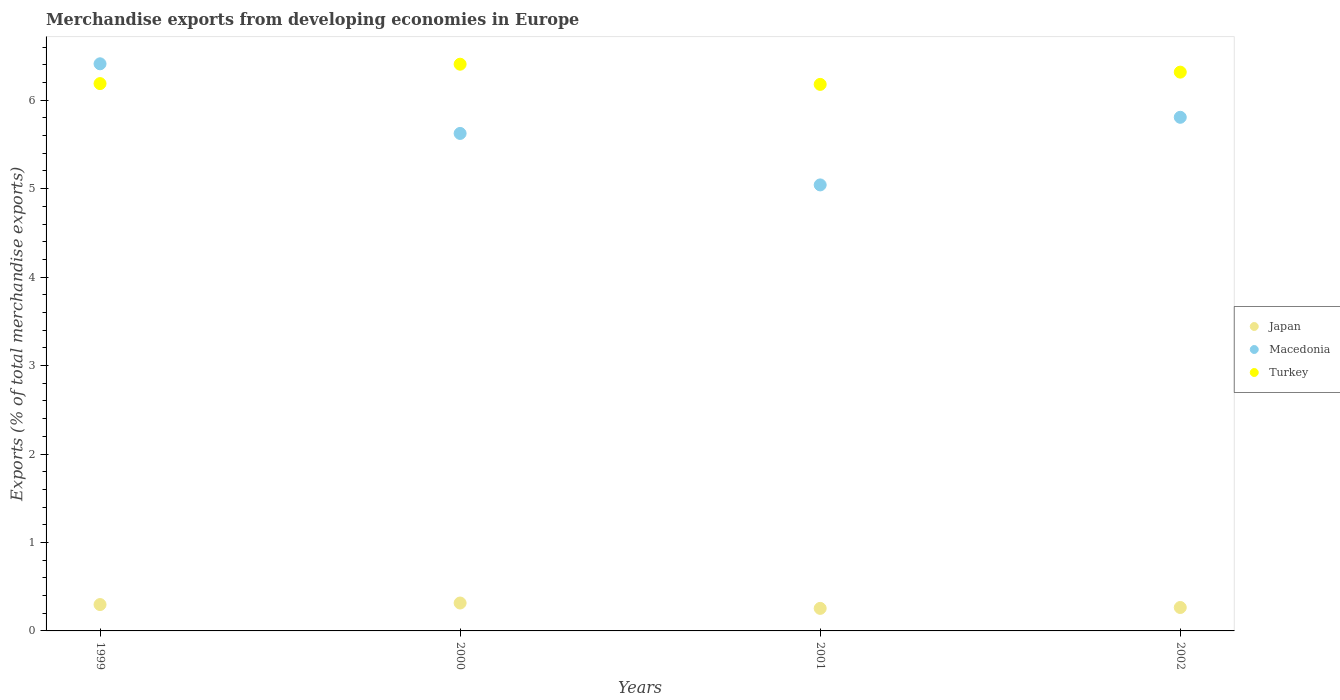How many different coloured dotlines are there?
Give a very brief answer. 3. Is the number of dotlines equal to the number of legend labels?
Offer a terse response. Yes. What is the percentage of total merchandise exports in Macedonia in 2001?
Provide a succinct answer. 5.04. Across all years, what is the maximum percentage of total merchandise exports in Turkey?
Offer a very short reply. 6.41. Across all years, what is the minimum percentage of total merchandise exports in Japan?
Give a very brief answer. 0.25. In which year was the percentage of total merchandise exports in Japan maximum?
Offer a very short reply. 2000. In which year was the percentage of total merchandise exports in Macedonia minimum?
Give a very brief answer. 2001. What is the total percentage of total merchandise exports in Turkey in the graph?
Your answer should be compact. 25.09. What is the difference between the percentage of total merchandise exports in Macedonia in 2000 and that in 2001?
Keep it short and to the point. 0.58. What is the difference between the percentage of total merchandise exports in Turkey in 2002 and the percentage of total merchandise exports in Japan in 1999?
Provide a short and direct response. 6.02. What is the average percentage of total merchandise exports in Turkey per year?
Your answer should be very brief. 6.27. In the year 2001, what is the difference between the percentage of total merchandise exports in Japan and percentage of total merchandise exports in Turkey?
Keep it short and to the point. -5.92. In how many years, is the percentage of total merchandise exports in Turkey greater than 4 %?
Keep it short and to the point. 4. What is the ratio of the percentage of total merchandise exports in Macedonia in 1999 to that in 2001?
Keep it short and to the point. 1.27. Is the difference between the percentage of total merchandise exports in Japan in 2000 and 2002 greater than the difference between the percentage of total merchandise exports in Turkey in 2000 and 2002?
Give a very brief answer. No. What is the difference between the highest and the second highest percentage of total merchandise exports in Turkey?
Provide a succinct answer. 0.09. What is the difference between the highest and the lowest percentage of total merchandise exports in Turkey?
Provide a succinct answer. 0.23. In how many years, is the percentage of total merchandise exports in Macedonia greater than the average percentage of total merchandise exports in Macedonia taken over all years?
Give a very brief answer. 2. Is it the case that in every year, the sum of the percentage of total merchandise exports in Macedonia and percentage of total merchandise exports in Japan  is greater than the percentage of total merchandise exports in Turkey?
Give a very brief answer. No. What is the difference between two consecutive major ticks on the Y-axis?
Offer a terse response. 1. Does the graph contain grids?
Provide a short and direct response. No. What is the title of the graph?
Give a very brief answer. Merchandise exports from developing economies in Europe. What is the label or title of the Y-axis?
Your response must be concise. Exports (% of total merchandise exports). What is the Exports (% of total merchandise exports) of Japan in 1999?
Your response must be concise. 0.3. What is the Exports (% of total merchandise exports) in Macedonia in 1999?
Offer a terse response. 6.41. What is the Exports (% of total merchandise exports) in Turkey in 1999?
Keep it short and to the point. 6.19. What is the Exports (% of total merchandise exports) in Japan in 2000?
Offer a very short reply. 0.32. What is the Exports (% of total merchandise exports) of Macedonia in 2000?
Give a very brief answer. 5.62. What is the Exports (% of total merchandise exports) of Turkey in 2000?
Ensure brevity in your answer.  6.41. What is the Exports (% of total merchandise exports) of Japan in 2001?
Ensure brevity in your answer.  0.25. What is the Exports (% of total merchandise exports) in Macedonia in 2001?
Provide a succinct answer. 5.04. What is the Exports (% of total merchandise exports) of Turkey in 2001?
Give a very brief answer. 6.18. What is the Exports (% of total merchandise exports) of Japan in 2002?
Keep it short and to the point. 0.26. What is the Exports (% of total merchandise exports) of Macedonia in 2002?
Make the answer very short. 5.81. What is the Exports (% of total merchandise exports) of Turkey in 2002?
Give a very brief answer. 6.32. Across all years, what is the maximum Exports (% of total merchandise exports) in Japan?
Your answer should be compact. 0.32. Across all years, what is the maximum Exports (% of total merchandise exports) in Macedonia?
Provide a succinct answer. 6.41. Across all years, what is the maximum Exports (% of total merchandise exports) of Turkey?
Ensure brevity in your answer.  6.41. Across all years, what is the minimum Exports (% of total merchandise exports) of Japan?
Your answer should be compact. 0.25. Across all years, what is the minimum Exports (% of total merchandise exports) of Macedonia?
Ensure brevity in your answer.  5.04. Across all years, what is the minimum Exports (% of total merchandise exports) in Turkey?
Make the answer very short. 6.18. What is the total Exports (% of total merchandise exports) of Japan in the graph?
Your answer should be very brief. 1.13. What is the total Exports (% of total merchandise exports) in Macedonia in the graph?
Offer a very short reply. 22.89. What is the total Exports (% of total merchandise exports) of Turkey in the graph?
Your answer should be very brief. 25.09. What is the difference between the Exports (% of total merchandise exports) of Japan in 1999 and that in 2000?
Your answer should be very brief. -0.02. What is the difference between the Exports (% of total merchandise exports) of Macedonia in 1999 and that in 2000?
Your answer should be very brief. 0.79. What is the difference between the Exports (% of total merchandise exports) of Turkey in 1999 and that in 2000?
Your answer should be compact. -0.22. What is the difference between the Exports (% of total merchandise exports) in Japan in 1999 and that in 2001?
Give a very brief answer. 0.04. What is the difference between the Exports (% of total merchandise exports) of Macedonia in 1999 and that in 2001?
Offer a very short reply. 1.37. What is the difference between the Exports (% of total merchandise exports) in Turkey in 1999 and that in 2001?
Offer a very short reply. 0.01. What is the difference between the Exports (% of total merchandise exports) in Japan in 1999 and that in 2002?
Ensure brevity in your answer.  0.03. What is the difference between the Exports (% of total merchandise exports) in Macedonia in 1999 and that in 2002?
Give a very brief answer. 0.6. What is the difference between the Exports (% of total merchandise exports) in Turkey in 1999 and that in 2002?
Provide a succinct answer. -0.13. What is the difference between the Exports (% of total merchandise exports) of Japan in 2000 and that in 2001?
Your answer should be very brief. 0.06. What is the difference between the Exports (% of total merchandise exports) in Macedonia in 2000 and that in 2001?
Offer a terse response. 0.58. What is the difference between the Exports (% of total merchandise exports) of Turkey in 2000 and that in 2001?
Offer a very short reply. 0.23. What is the difference between the Exports (% of total merchandise exports) of Japan in 2000 and that in 2002?
Give a very brief answer. 0.05. What is the difference between the Exports (% of total merchandise exports) of Macedonia in 2000 and that in 2002?
Provide a short and direct response. -0.18. What is the difference between the Exports (% of total merchandise exports) in Turkey in 2000 and that in 2002?
Offer a very short reply. 0.09. What is the difference between the Exports (% of total merchandise exports) of Japan in 2001 and that in 2002?
Ensure brevity in your answer.  -0.01. What is the difference between the Exports (% of total merchandise exports) in Macedonia in 2001 and that in 2002?
Your answer should be compact. -0.76. What is the difference between the Exports (% of total merchandise exports) in Turkey in 2001 and that in 2002?
Provide a succinct answer. -0.14. What is the difference between the Exports (% of total merchandise exports) in Japan in 1999 and the Exports (% of total merchandise exports) in Macedonia in 2000?
Keep it short and to the point. -5.33. What is the difference between the Exports (% of total merchandise exports) in Japan in 1999 and the Exports (% of total merchandise exports) in Turkey in 2000?
Provide a succinct answer. -6.11. What is the difference between the Exports (% of total merchandise exports) in Macedonia in 1999 and the Exports (% of total merchandise exports) in Turkey in 2000?
Offer a very short reply. 0. What is the difference between the Exports (% of total merchandise exports) of Japan in 1999 and the Exports (% of total merchandise exports) of Macedonia in 2001?
Offer a very short reply. -4.74. What is the difference between the Exports (% of total merchandise exports) of Japan in 1999 and the Exports (% of total merchandise exports) of Turkey in 2001?
Offer a very short reply. -5.88. What is the difference between the Exports (% of total merchandise exports) in Macedonia in 1999 and the Exports (% of total merchandise exports) in Turkey in 2001?
Your answer should be compact. 0.23. What is the difference between the Exports (% of total merchandise exports) of Japan in 1999 and the Exports (% of total merchandise exports) of Macedonia in 2002?
Keep it short and to the point. -5.51. What is the difference between the Exports (% of total merchandise exports) of Japan in 1999 and the Exports (% of total merchandise exports) of Turkey in 2002?
Your answer should be compact. -6.02. What is the difference between the Exports (% of total merchandise exports) in Macedonia in 1999 and the Exports (% of total merchandise exports) in Turkey in 2002?
Provide a short and direct response. 0.09. What is the difference between the Exports (% of total merchandise exports) in Japan in 2000 and the Exports (% of total merchandise exports) in Macedonia in 2001?
Keep it short and to the point. -4.73. What is the difference between the Exports (% of total merchandise exports) in Japan in 2000 and the Exports (% of total merchandise exports) in Turkey in 2001?
Provide a succinct answer. -5.86. What is the difference between the Exports (% of total merchandise exports) in Macedonia in 2000 and the Exports (% of total merchandise exports) in Turkey in 2001?
Offer a terse response. -0.55. What is the difference between the Exports (% of total merchandise exports) in Japan in 2000 and the Exports (% of total merchandise exports) in Macedonia in 2002?
Ensure brevity in your answer.  -5.49. What is the difference between the Exports (% of total merchandise exports) in Japan in 2000 and the Exports (% of total merchandise exports) in Turkey in 2002?
Your answer should be compact. -6. What is the difference between the Exports (% of total merchandise exports) in Macedonia in 2000 and the Exports (% of total merchandise exports) in Turkey in 2002?
Your response must be concise. -0.69. What is the difference between the Exports (% of total merchandise exports) of Japan in 2001 and the Exports (% of total merchandise exports) of Macedonia in 2002?
Offer a very short reply. -5.55. What is the difference between the Exports (% of total merchandise exports) in Japan in 2001 and the Exports (% of total merchandise exports) in Turkey in 2002?
Ensure brevity in your answer.  -6.06. What is the difference between the Exports (% of total merchandise exports) in Macedonia in 2001 and the Exports (% of total merchandise exports) in Turkey in 2002?
Ensure brevity in your answer.  -1.27. What is the average Exports (% of total merchandise exports) in Japan per year?
Your answer should be very brief. 0.28. What is the average Exports (% of total merchandise exports) of Macedonia per year?
Give a very brief answer. 5.72. What is the average Exports (% of total merchandise exports) in Turkey per year?
Give a very brief answer. 6.27. In the year 1999, what is the difference between the Exports (% of total merchandise exports) in Japan and Exports (% of total merchandise exports) in Macedonia?
Your answer should be very brief. -6.11. In the year 1999, what is the difference between the Exports (% of total merchandise exports) of Japan and Exports (% of total merchandise exports) of Turkey?
Make the answer very short. -5.89. In the year 1999, what is the difference between the Exports (% of total merchandise exports) of Macedonia and Exports (% of total merchandise exports) of Turkey?
Your answer should be compact. 0.22. In the year 2000, what is the difference between the Exports (% of total merchandise exports) in Japan and Exports (% of total merchandise exports) in Macedonia?
Keep it short and to the point. -5.31. In the year 2000, what is the difference between the Exports (% of total merchandise exports) in Japan and Exports (% of total merchandise exports) in Turkey?
Give a very brief answer. -6.09. In the year 2000, what is the difference between the Exports (% of total merchandise exports) in Macedonia and Exports (% of total merchandise exports) in Turkey?
Your response must be concise. -0.78. In the year 2001, what is the difference between the Exports (% of total merchandise exports) of Japan and Exports (% of total merchandise exports) of Macedonia?
Give a very brief answer. -4.79. In the year 2001, what is the difference between the Exports (% of total merchandise exports) in Japan and Exports (% of total merchandise exports) in Turkey?
Offer a very short reply. -5.92. In the year 2001, what is the difference between the Exports (% of total merchandise exports) in Macedonia and Exports (% of total merchandise exports) in Turkey?
Your answer should be compact. -1.14. In the year 2002, what is the difference between the Exports (% of total merchandise exports) in Japan and Exports (% of total merchandise exports) in Macedonia?
Your answer should be compact. -5.54. In the year 2002, what is the difference between the Exports (% of total merchandise exports) in Japan and Exports (% of total merchandise exports) in Turkey?
Keep it short and to the point. -6.05. In the year 2002, what is the difference between the Exports (% of total merchandise exports) in Macedonia and Exports (% of total merchandise exports) in Turkey?
Your response must be concise. -0.51. What is the ratio of the Exports (% of total merchandise exports) in Japan in 1999 to that in 2000?
Provide a short and direct response. 0.94. What is the ratio of the Exports (% of total merchandise exports) of Macedonia in 1999 to that in 2000?
Offer a very short reply. 1.14. What is the ratio of the Exports (% of total merchandise exports) in Turkey in 1999 to that in 2000?
Your response must be concise. 0.97. What is the ratio of the Exports (% of total merchandise exports) of Japan in 1999 to that in 2001?
Keep it short and to the point. 1.17. What is the ratio of the Exports (% of total merchandise exports) of Macedonia in 1999 to that in 2001?
Give a very brief answer. 1.27. What is the ratio of the Exports (% of total merchandise exports) in Japan in 1999 to that in 2002?
Your response must be concise. 1.13. What is the ratio of the Exports (% of total merchandise exports) in Macedonia in 1999 to that in 2002?
Make the answer very short. 1.1. What is the ratio of the Exports (% of total merchandise exports) of Turkey in 1999 to that in 2002?
Provide a succinct answer. 0.98. What is the ratio of the Exports (% of total merchandise exports) of Japan in 2000 to that in 2001?
Provide a succinct answer. 1.24. What is the ratio of the Exports (% of total merchandise exports) of Macedonia in 2000 to that in 2001?
Offer a terse response. 1.12. What is the ratio of the Exports (% of total merchandise exports) of Turkey in 2000 to that in 2001?
Offer a terse response. 1.04. What is the ratio of the Exports (% of total merchandise exports) in Japan in 2000 to that in 2002?
Offer a very short reply. 1.19. What is the ratio of the Exports (% of total merchandise exports) in Macedonia in 2000 to that in 2002?
Make the answer very short. 0.97. What is the ratio of the Exports (% of total merchandise exports) of Turkey in 2000 to that in 2002?
Provide a short and direct response. 1.01. What is the ratio of the Exports (% of total merchandise exports) in Japan in 2001 to that in 2002?
Your answer should be compact. 0.96. What is the ratio of the Exports (% of total merchandise exports) in Macedonia in 2001 to that in 2002?
Your answer should be very brief. 0.87. What is the ratio of the Exports (% of total merchandise exports) of Turkey in 2001 to that in 2002?
Keep it short and to the point. 0.98. What is the difference between the highest and the second highest Exports (% of total merchandise exports) of Japan?
Provide a short and direct response. 0.02. What is the difference between the highest and the second highest Exports (% of total merchandise exports) of Macedonia?
Provide a succinct answer. 0.6. What is the difference between the highest and the second highest Exports (% of total merchandise exports) in Turkey?
Offer a terse response. 0.09. What is the difference between the highest and the lowest Exports (% of total merchandise exports) in Japan?
Offer a very short reply. 0.06. What is the difference between the highest and the lowest Exports (% of total merchandise exports) in Macedonia?
Give a very brief answer. 1.37. What is the difference between the highest and the lowest Exports (% of total merchandise exports) of Turkey?
Your answer should be very brief. 0.23. 